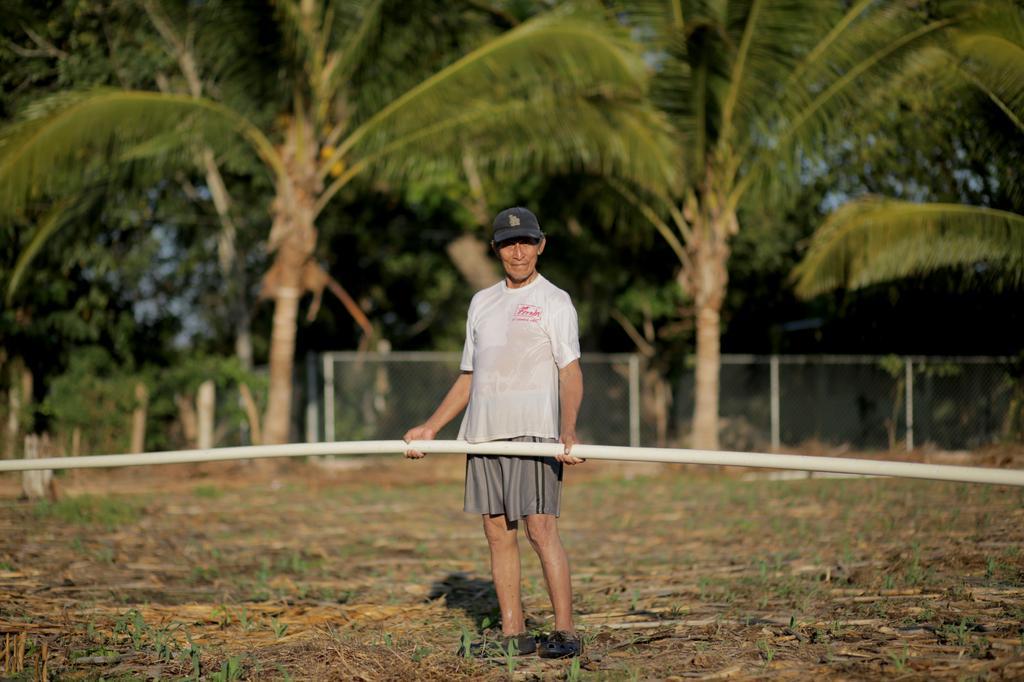Please provide a concise description of this image. In this picture, I can see a garden and a person holding a stick and behind the person, They are numerous trees and after that i can see boundary wall which is build with iron and finally i can see few coconuts. 